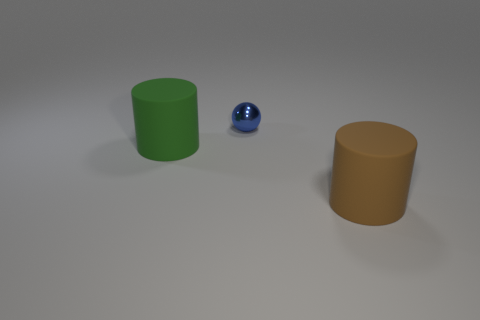Add 1 big green cylinders. How many objects exist? 4 Subtract 0 red blocks. How many objects are left? 3 Subtract all balls. How many objects are left? 2 Subtract all cylinders. Subtract all large brown rubber objects. How many objects are left? 0 Add 1 blue metallic things. How many blue metallic things are left? 2 Add 1 blue spheres. How many blue spheres exist? 2 